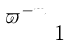<formula> <loc_0><loc_0><loc_500><loc_500>\begin{smallmatrix} \varpi ^ { - m } \\ & 1 \end{smallmatrix}</formula> 